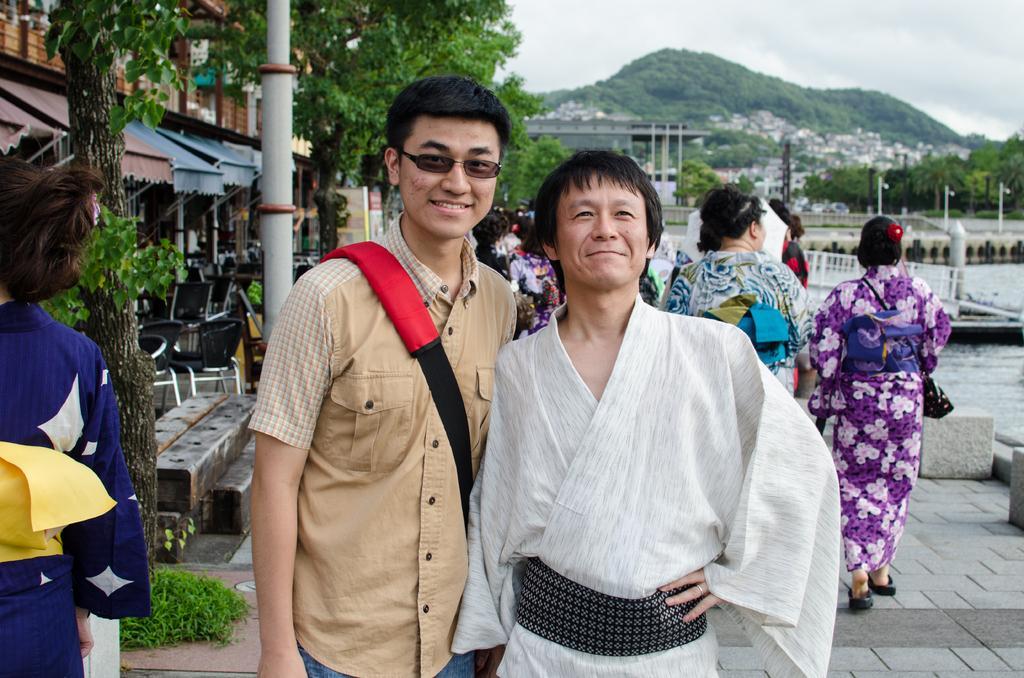Please provide a concise description of this image. In this image we can see some group of persons standing and walking on the floor, at the foreground of the image there are two persons wearing brown and white color dress respectively, person wearing brown color dress carrying bag, posing for a photograph and at the background of the image there are some houses, trees, bridge, water, mountain and cloudy sky. 